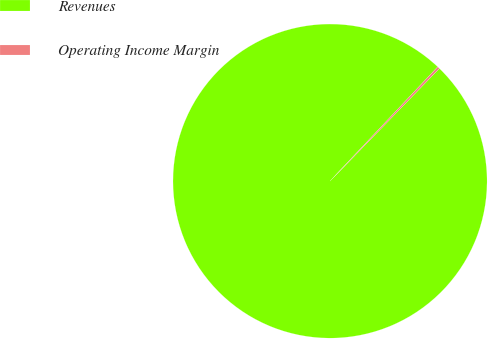Convert chart to OTSL. <chart><loc_0><loc_0><loc_500><loc_500><pie_chart><fcel>Revenues<fcel>Operating Income Margin<nl><fcel>99.76%<fcel>0.24%<nl></chart> 